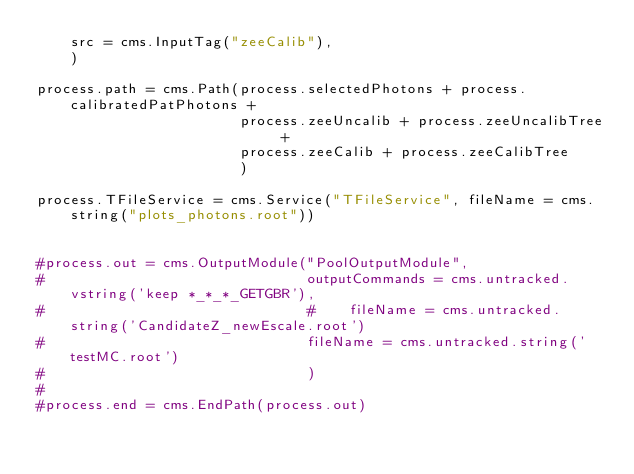<code> <loc_0><loc_0><loc_500><loc_500><_Python_>    src = cms.InputTag("zeeCalib"),
    )

process.path = cms.Path(process.selectedPhotons + process.calibratedPatPhotons +
                        process.zeeUncalib + process.zeeUncalibTree +
                        process.zeeCalib + process.zeeCalibTree
                        )

process.TFileService = cms.Service("TFileService", fileName = cms.string("plots_photons.root"))


#process.out = cms.OutputModule("PoolOutputModule",
#                               outputCommands = cms.untracked.vstring('keep *_*_*_GETGBR'),
#                               #    fileName = cms.untracked.string('CandidateZ_newEscale.root')
#                               fileName = cms.untracked.string('testMC.root')
#                               )
#
#process.end = cms.EndPath(process.out)
</code> 